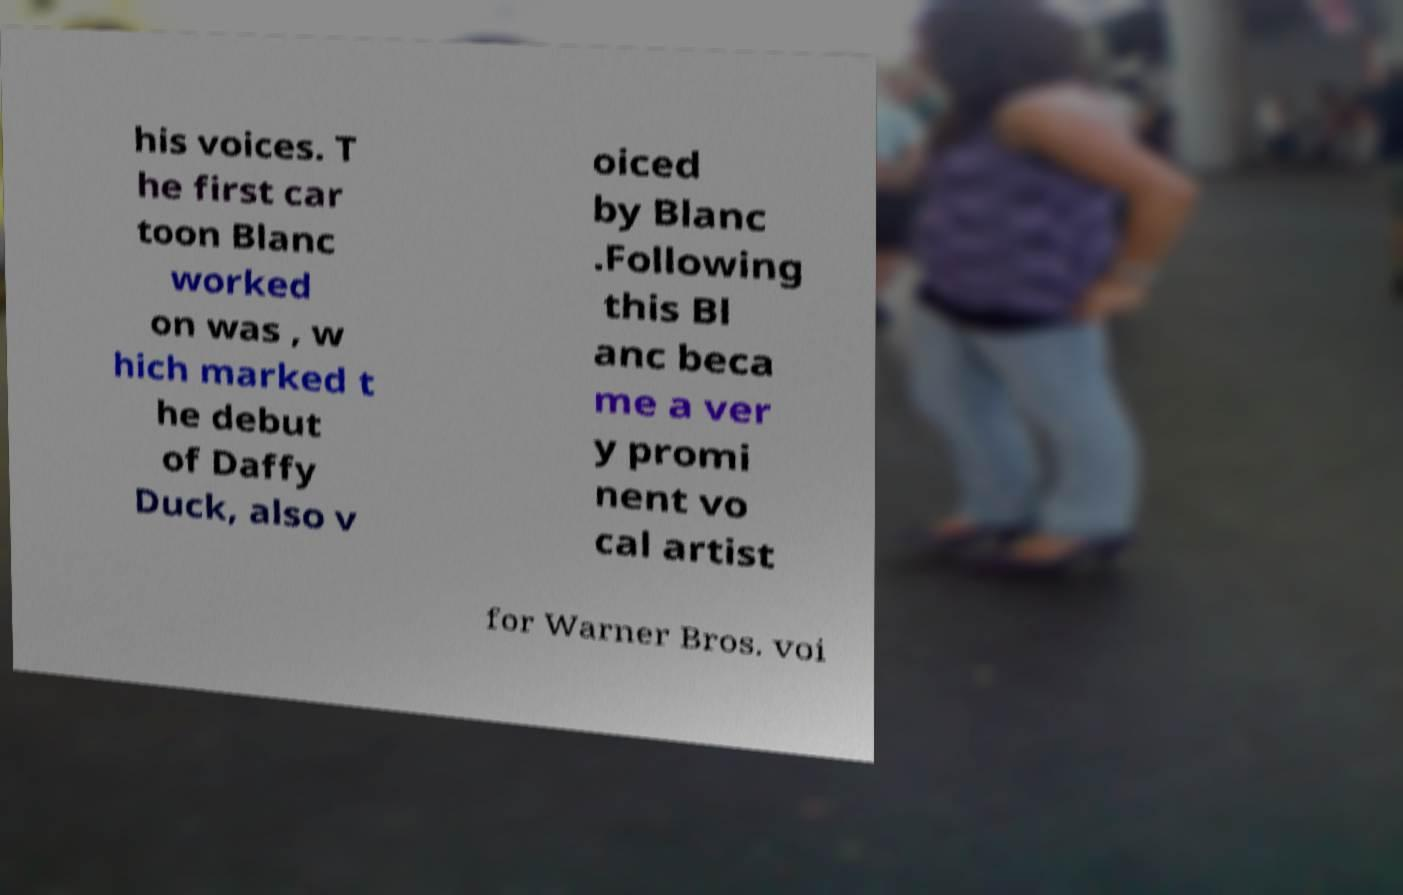I need the written content from this picture converted into text. Can you do that? his voices. T he first car toon Blanc worked on was , w hich marked t he debut of Daffy Duck, also v oiced by Blanc .Following this Bl anc beca me a ver y promi nent vo cal artist for Warner Bros. voi 